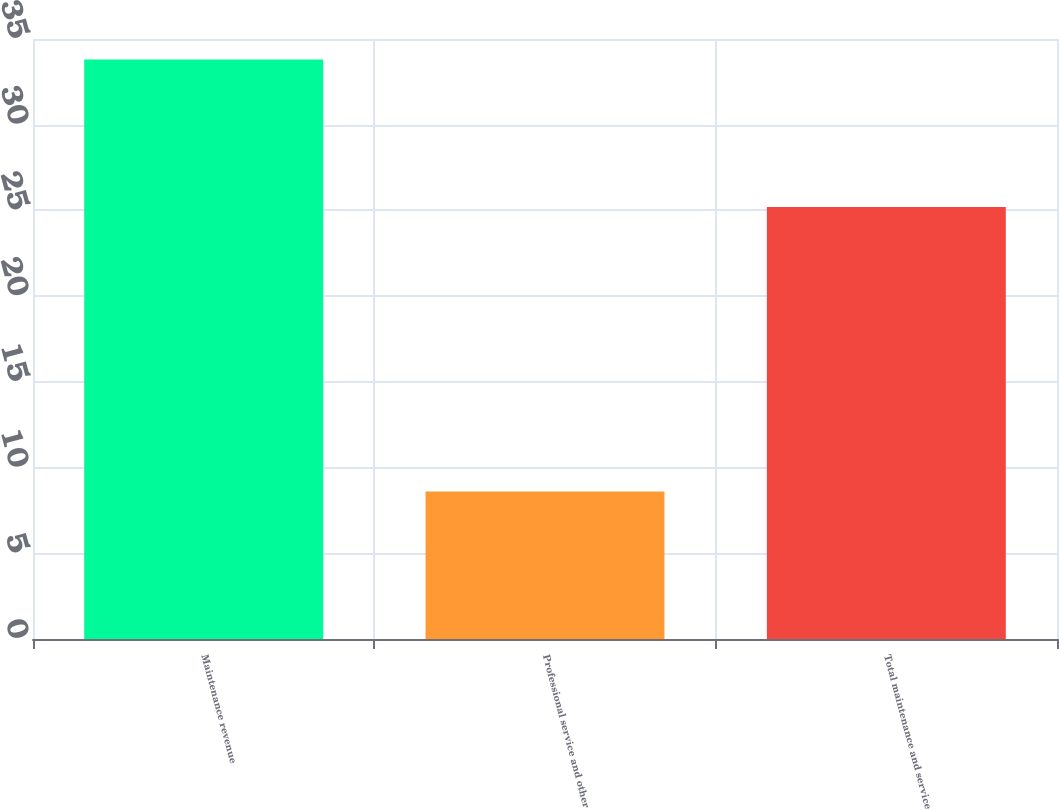Convert chart. <chart><loc_0><loc_0><loc_500><loc_500><bar_chart><fcel>Maintenance revenue<fcel>Professional service and other<fcel>Total maintenance and service<nl><fcel>33.8<fcel>8.6<fcel>25.2<nl></chart> 